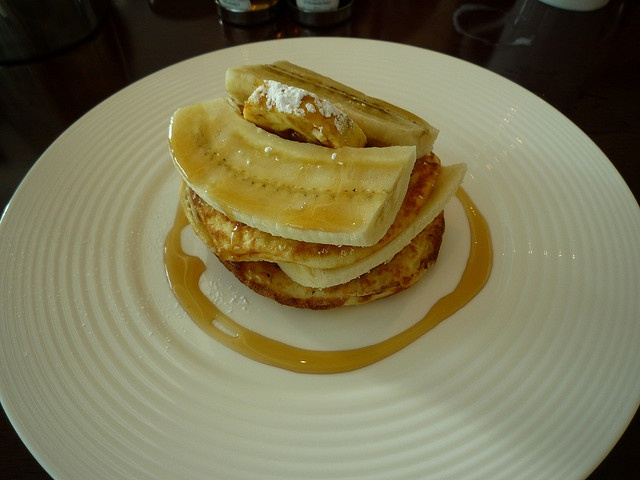Describe the objects in this image and their specific colors. I can see dining table in gray, darkgray, black, and olive tones, banana in black and olive tones, sandwich in black, maroon, and olive tones, and banana in black, olive, and darkgray tones in this image. 